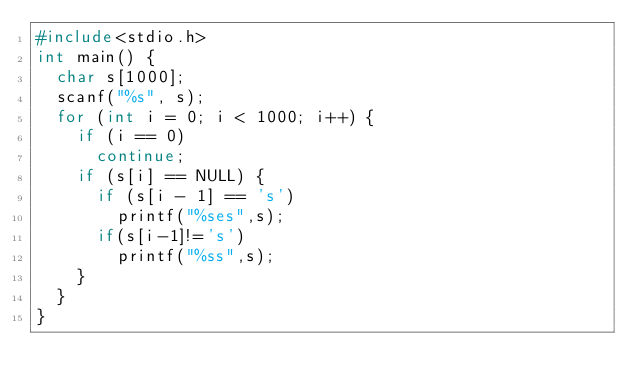<code> <loc_0><loc_0><loc_500><loc_500><_C_>#include<stdio.h>
int main() {
	char s[1000];
	scanf("%s", s);
	for (int i = 0; i < 1000; i++) {
		if (i == 0)
			continue;
		if (s[i] == NULL) {
			if (s[i - 1] == 's')
				printf("%ses",s);
			if(s[i-1]!='s')
				printf("%ss",s);
		}
	}
}</code> 